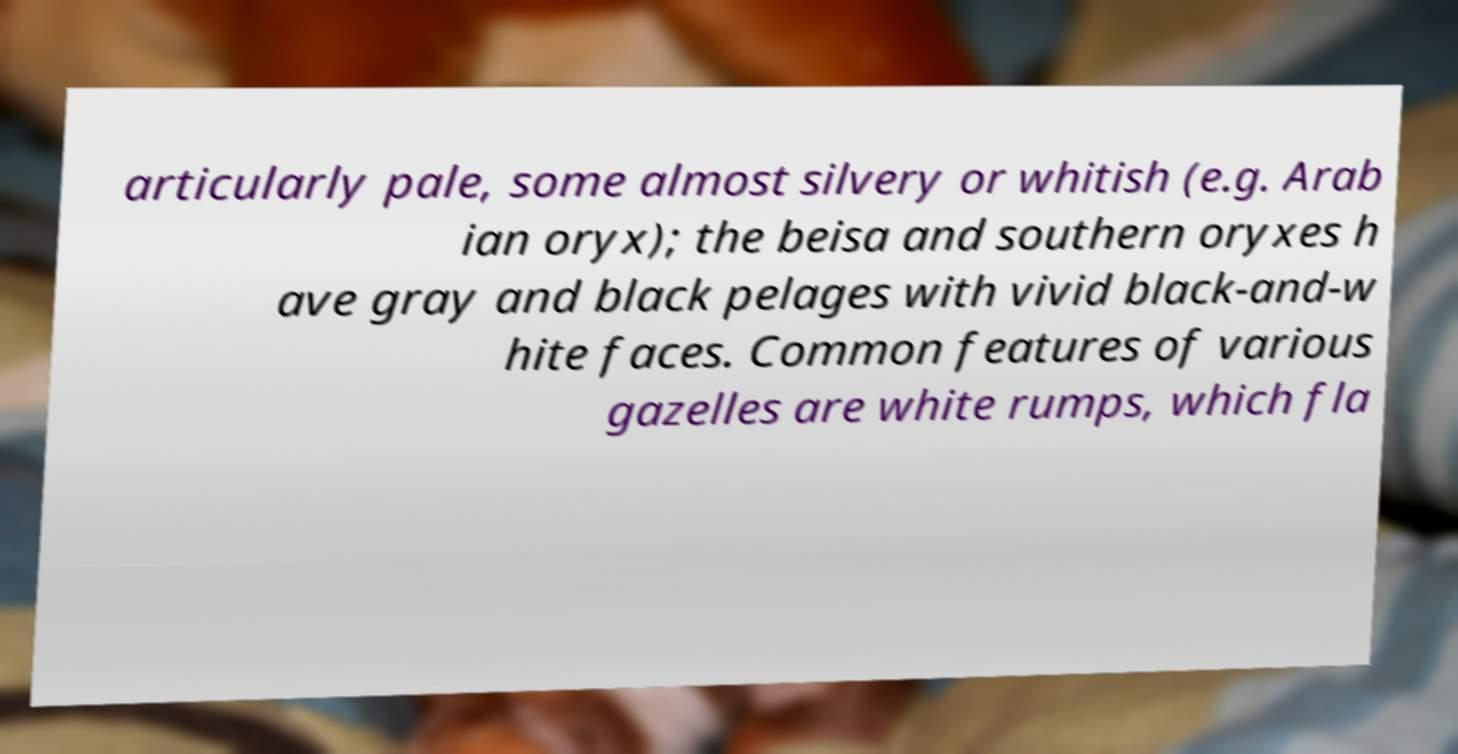I need the written content from this picture converted into text. Can you do that? articularly pale, some almost silvery or whitish (e.g. Arab ian oryx); the beisa and southern oryxes h ave gray and black pelages with vivid black-and-w hite faces. Common features of various gazelles are white rumps, which fla 